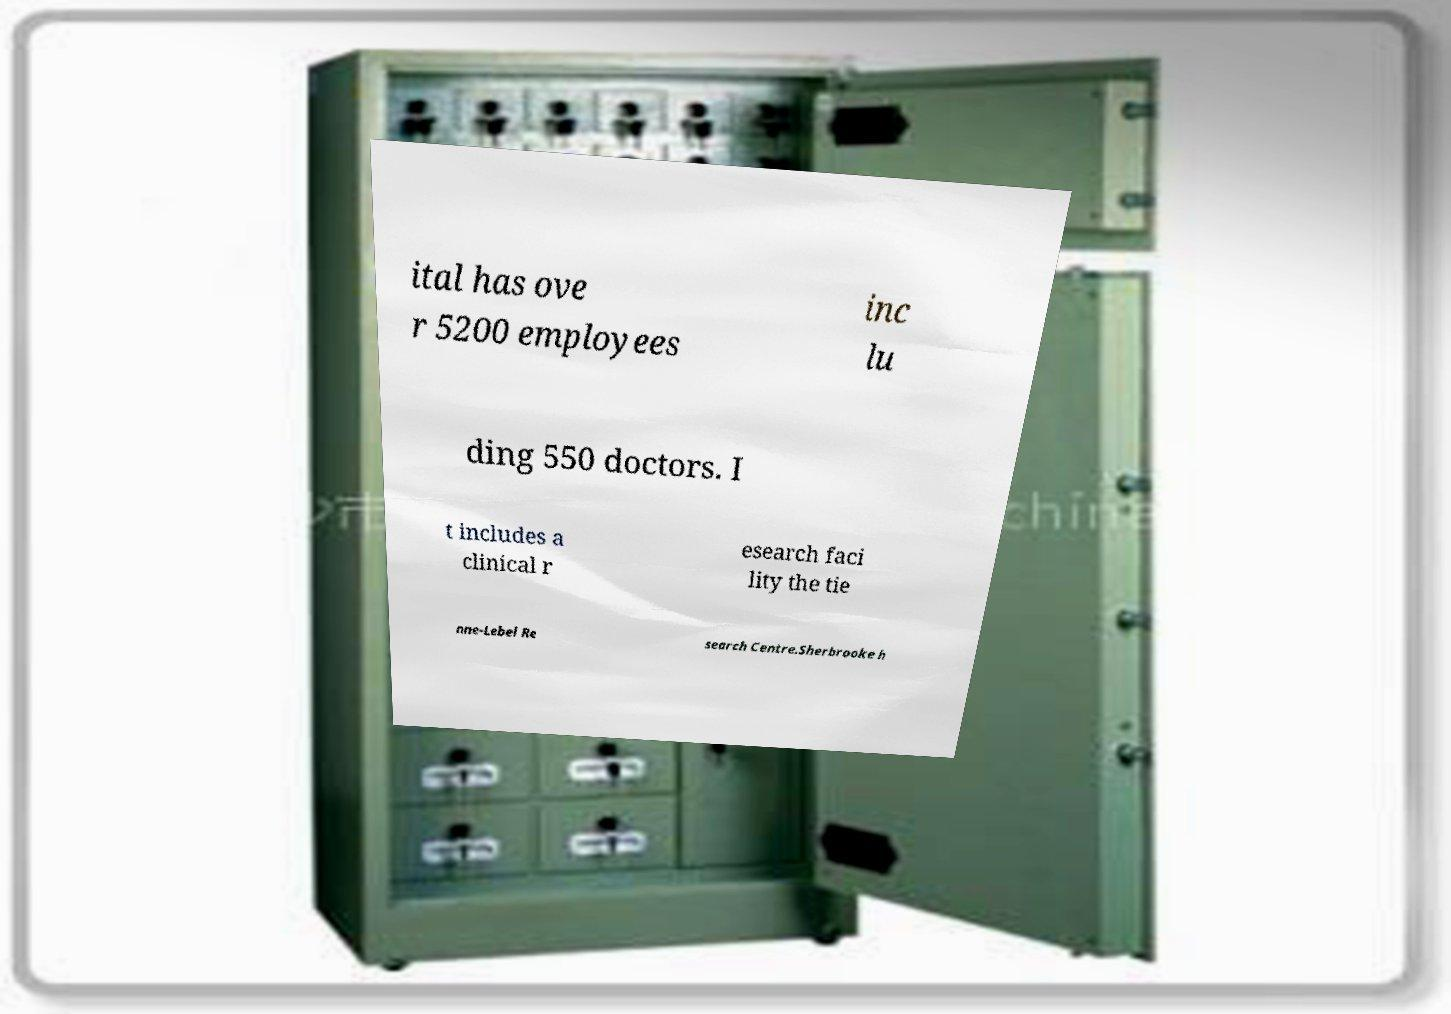Could you assist in decoding the text presented in this image and type it out clearly? ital has ove r 5200 employees inc lu ding 550 doctors. I t includes a clinical r esearch faci lity the tie nne-Lebel Re search Centre.Sherbrooke h 